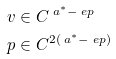Convert formula to latex. <formula><loc_0><loc_0><loc_500><loc_500>v & \in C ^ { \ a ^ { * } - \ e p } \\ p & \in C ^ { 2 ( \ a ^ { * } - \ e p ) }</formula> 